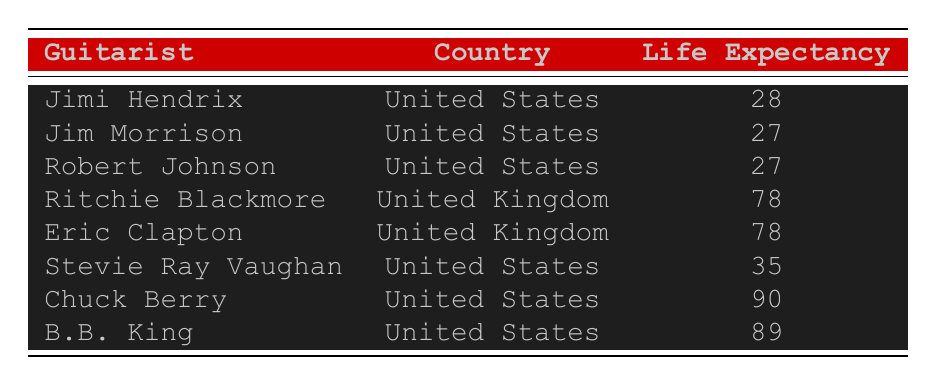What is the life expectancy of Jimi Hendrix? The table lists Jimi Hendrix's life expectancy directly as 28 years.
Answer: 28 How many guitarists in the table were born in the United States? There are 5 guitarists listed under the United States: Jimi Hendrix, Jim Morrison, Robert Johnson, Stevie Ray Vaughan, Chuck Berry, and B.B. King, totaling to 5.
Answer: 5 What is the difference in life expectancy between Chuck Berry and Jim Morrison? Chuck Berry's life expectancy is 90 years and Jim Morrison's is 27 years. To find the difference, calculate 90 - 27 = 63.
Answer: 63 Is the life expectancy of Eric Clapton higher than that of Stevie Ray Vaughan? Eric Clapton's life expectancy is 78 years, while Stevie Ray Vaughan's is 35 years. Since 78 is greater than 35, the statement is true.
Answer: Yes What is the average life expectancy of guitarists from the United Kingdom? The life expectancies for Ritchie Blackmore and Eric Clapton are both 78 years. The average is (78 + 78) / 2 = 78.
Answer: 78 Which guitarist has the highest life expectancy, and how does it compare with Robert Johnson's life expectancy? Chuck Berry has the highest life expectancy at 90 years, while Robert Johnson's life expectancy is 27 years. The difference is 90 - 27 = 63 years.
Answer: 90, 63 How many guitarists in the table have a life expectancy of less than 30 years? Jimi Hendrix, Jim Morrison, and Robert Johnson all have life expectancies under 30 years, totaling 3 guitarists.
Answer: 3 Was B.B. King's life expectancy higher than that of Ritchie Blackmore? B.B. King's life expectancy is 89 years and Ritchie Blackmore's is 78 years. Since 89 is higher, the statement is true.
Answer: Yes 